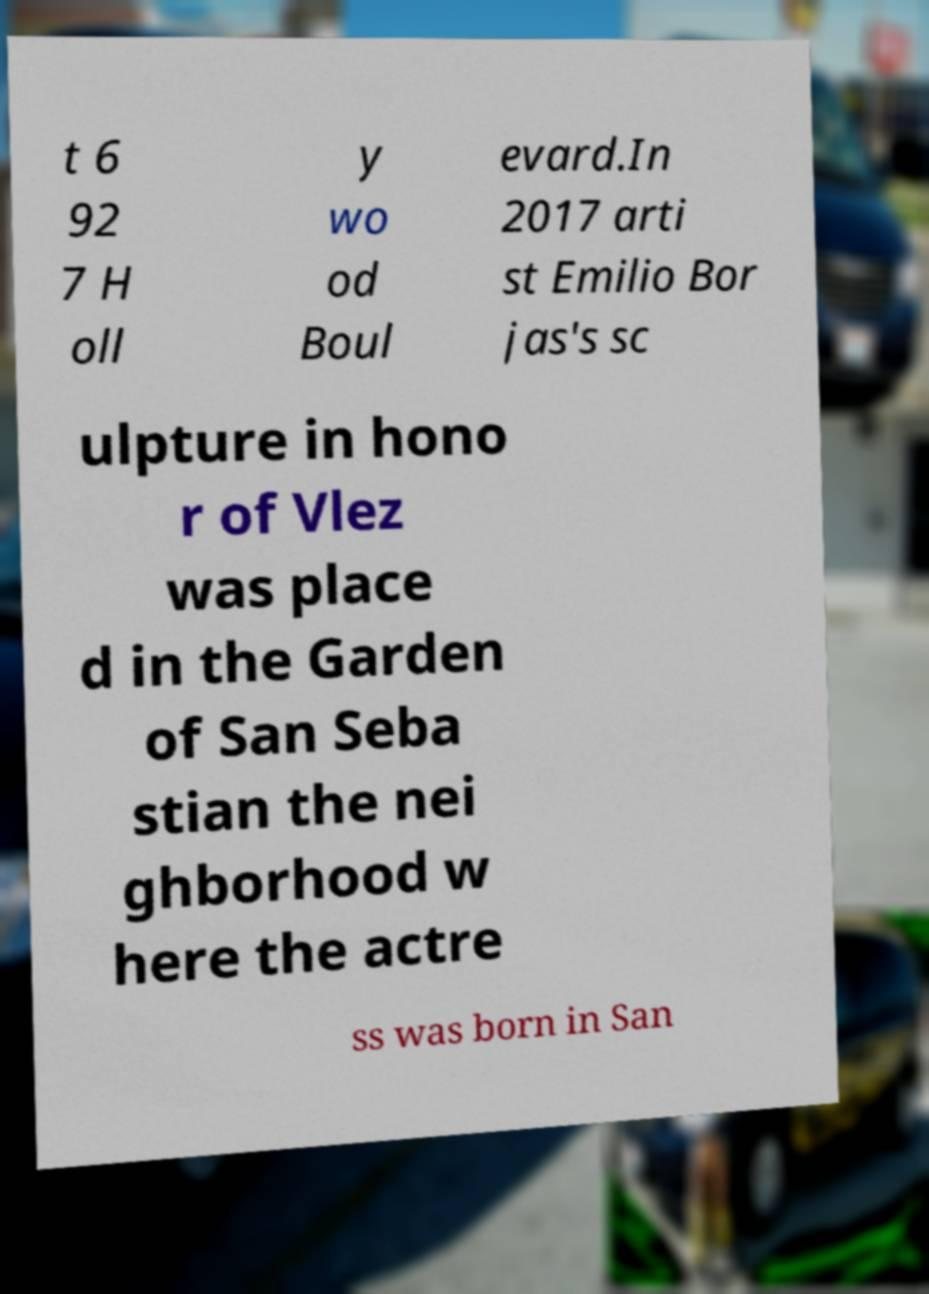There's text embedded in this image that I need extracted. Can you transcribe it verbatim? t 6 92 7 H oll y wo od Boul evard.In 2017 arti st Emilio Bor jas's sc ulpture in hono r of Vlez was place d in the Garden of San Seba stian the nei ghborhood w here the actre ss was born in San 